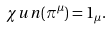Convert formula to latex. <formula><loc_0><loc_0><loc_500><loc_500>\chi u n ( \pi ^ { \mu } ) = 1 _ { \mu } .</formula> 